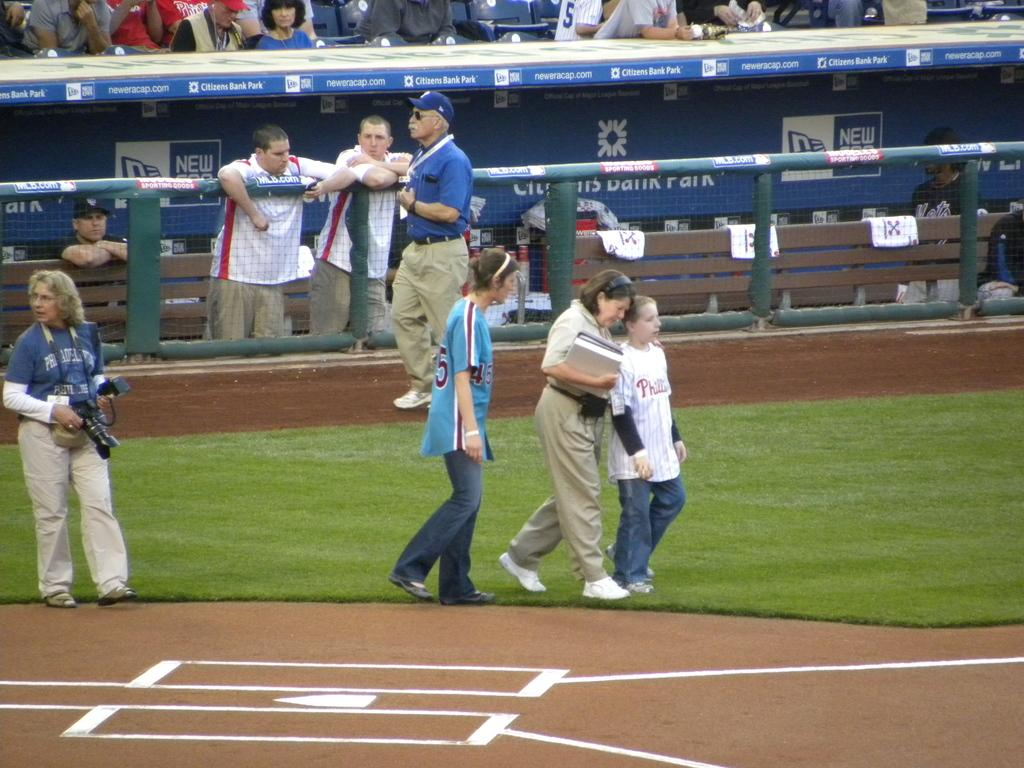<image>
Offer a succinct explanation of the picture presented. People walking on a baseball field, including a child with a Phillies jersey. 